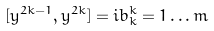Convert formula to latex. <formula><loc_0><loc_0><loc_500><loc_500>[ y ^ { 2 k - 1 } , y ^ { 2 k } ] = i b _ { k } ^ { k } = 1 \dots m</formula> 